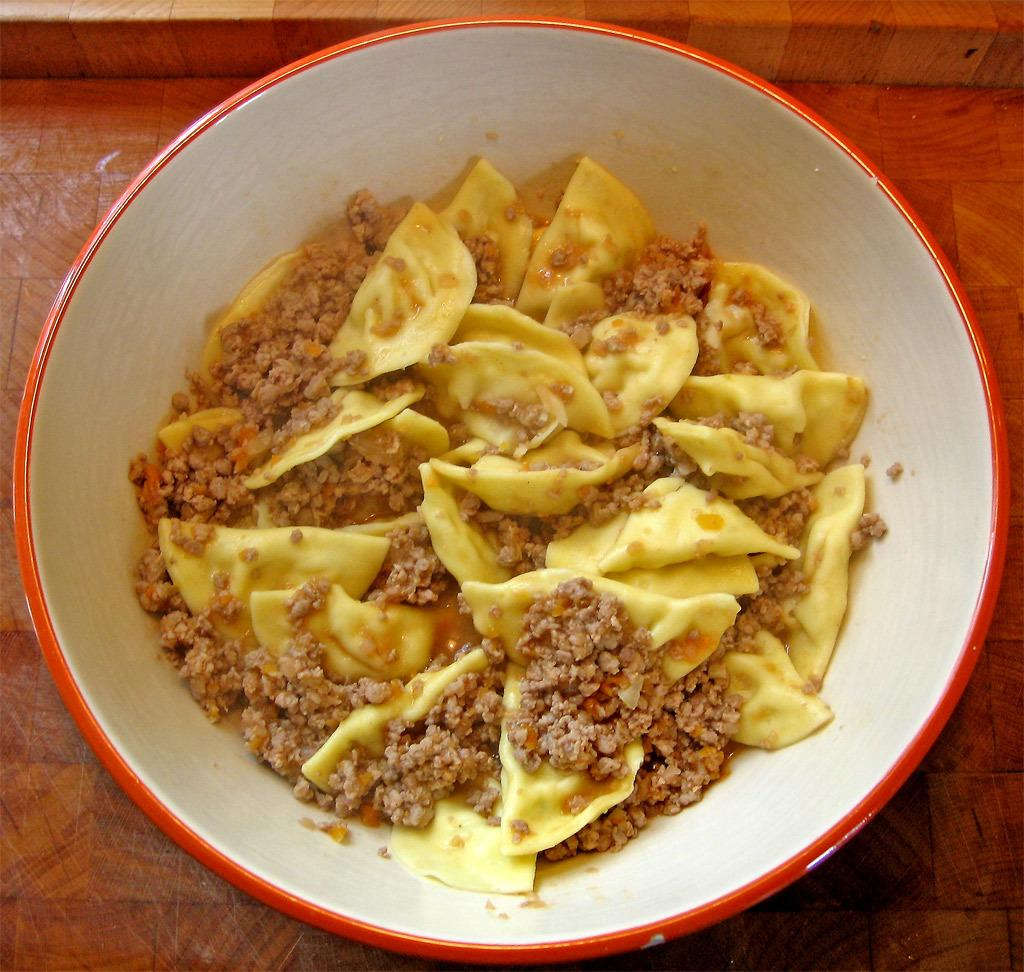What is in the bowl that is visible in the image? There is food in the bowl in the image. What type of surface is at the bottom of the image? There is a wooden surface at the bottom of the image. What discovery was made by the expert in the image? There is no expert or discovery present in the image. The image only shows a bowl with food on a wooden surface. 